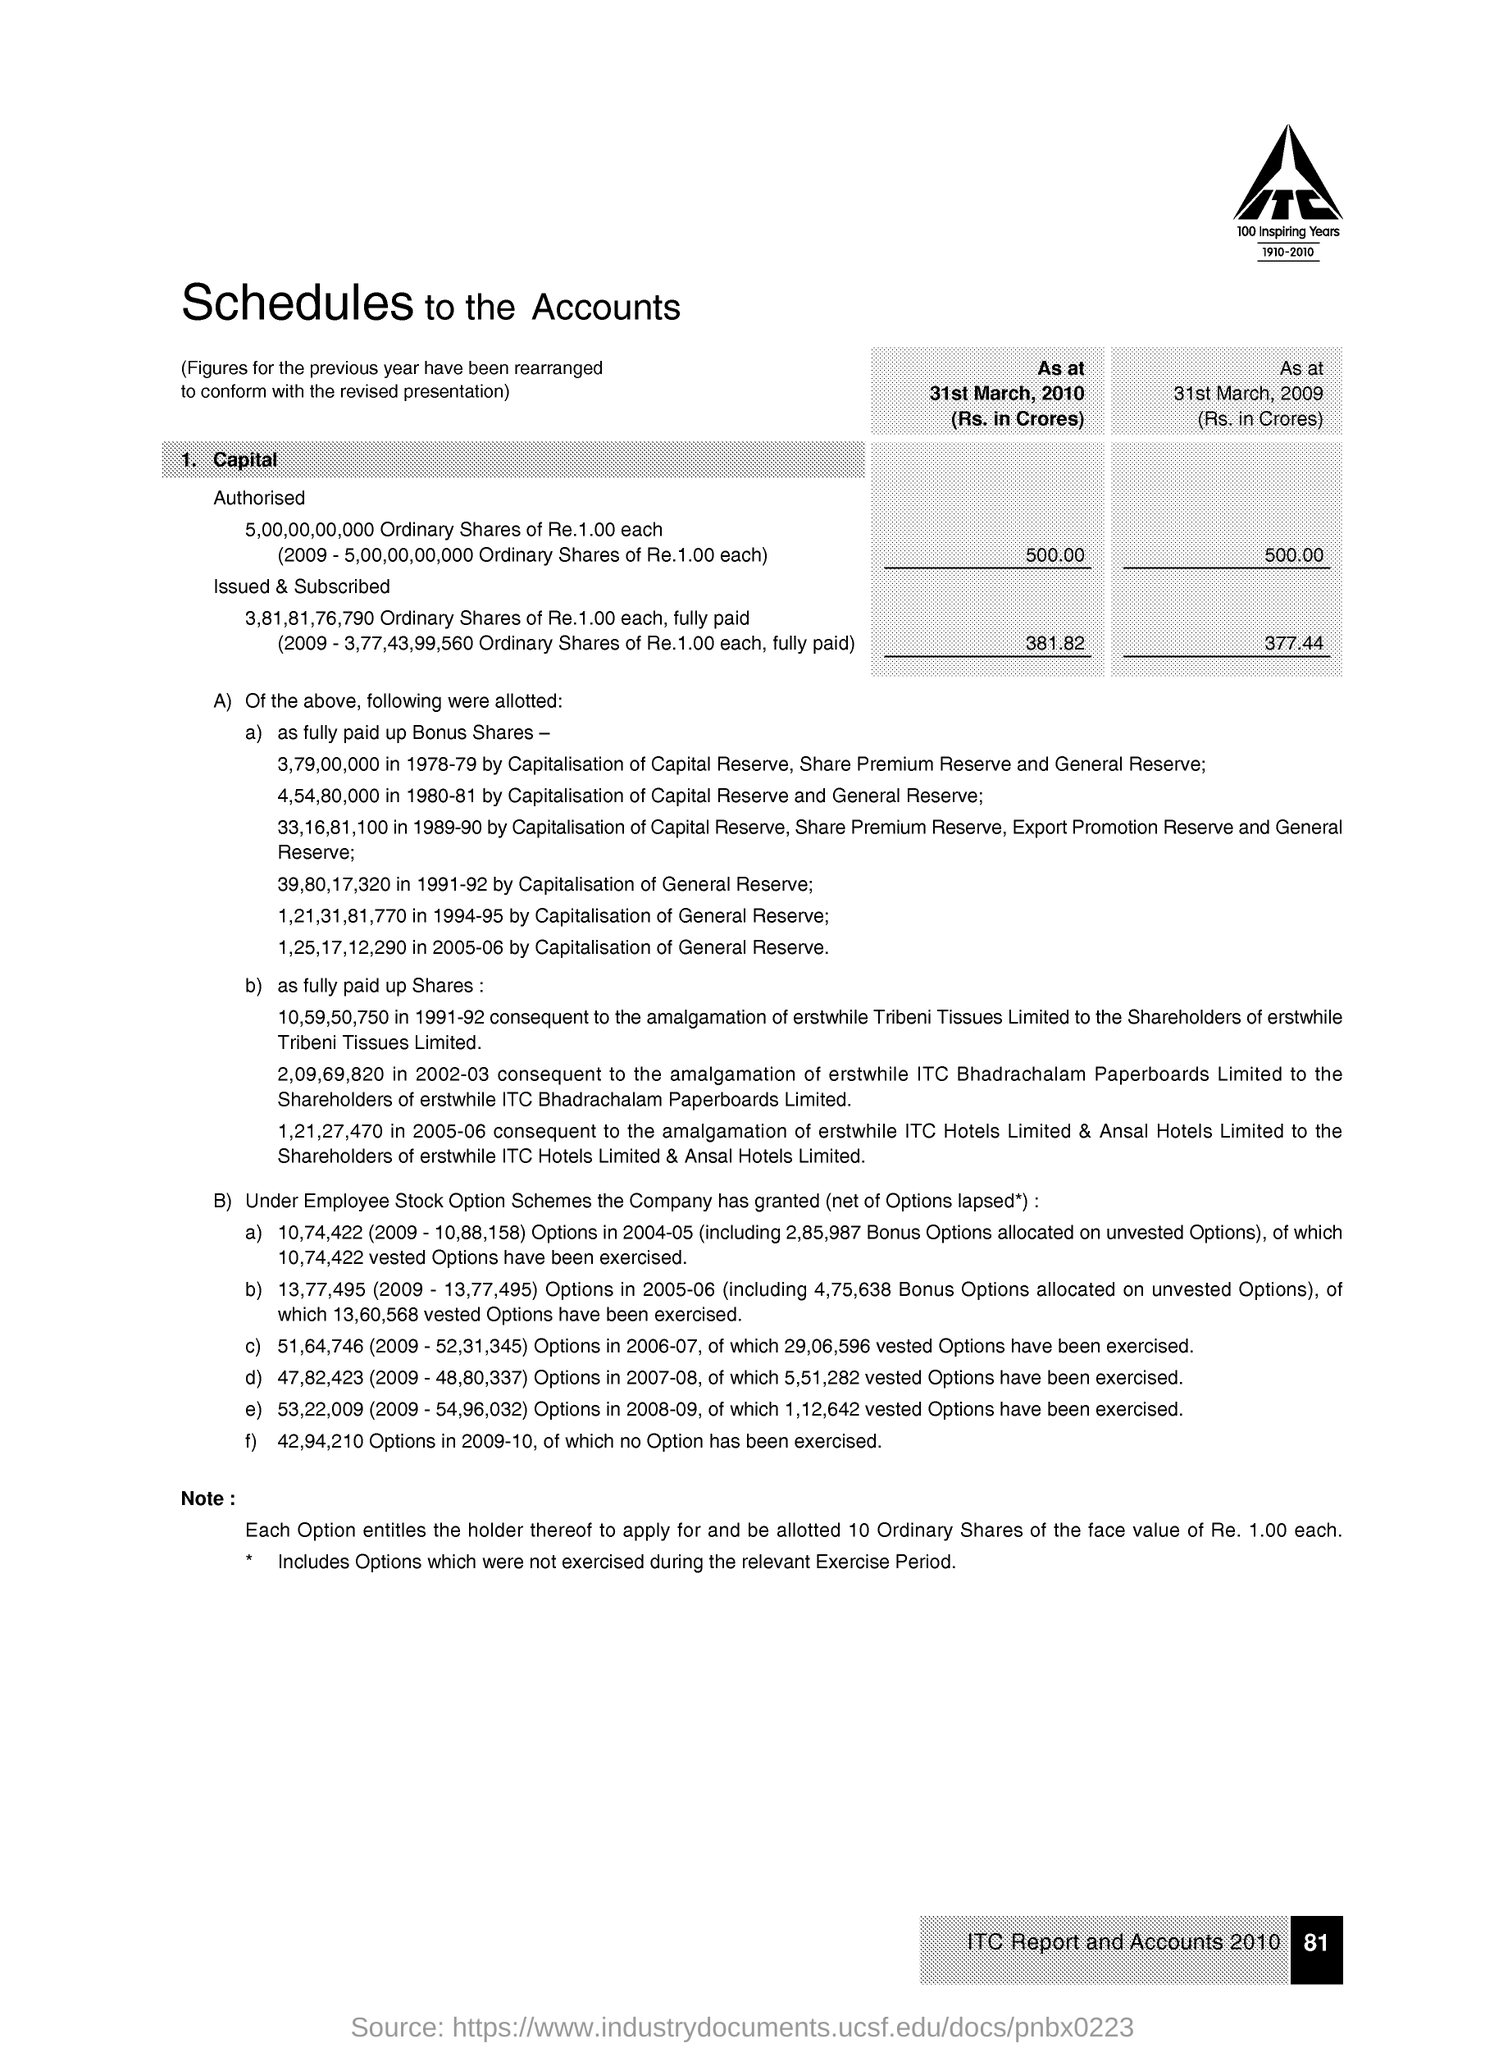What is the title of the document?
Keep it short and to the point. Schedules to the Accounts. What is written below the image?
Provide a succinct answer. 100 INSPIRING YEARS. What is the Page Number?
Give a very brief answer. 81. What is written in the image?
Give a very brief answer. ITC. 